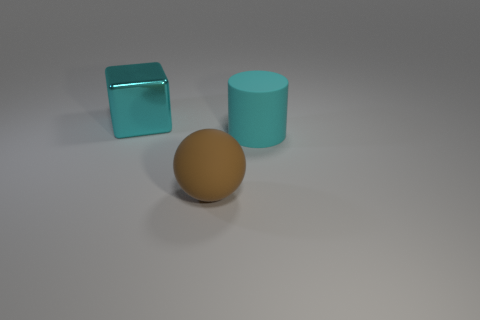Add 3 big gray metal cylinders. How many objects exist? 6 Subtract all cylinders. How many objects are left? 2 Subtract all large cyan metallic blocks. Subtract all shiny cubes. How many objects are left? 1 Add 2 big cubes. How many big cubes are left? 3 Add 2 large cyan rubber cylinders. How many large cyan rubber cylinders exist? 3 Subtract 0 cyan spheres. How many objects are left? 3 